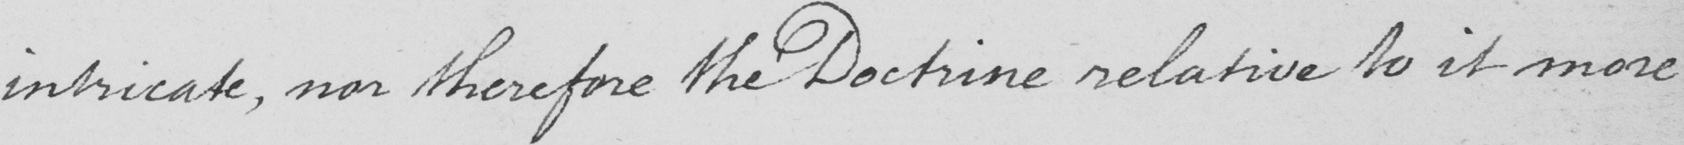What text is written in this handwritten line? intricate , nor therefore the Doctrine relative to it more 